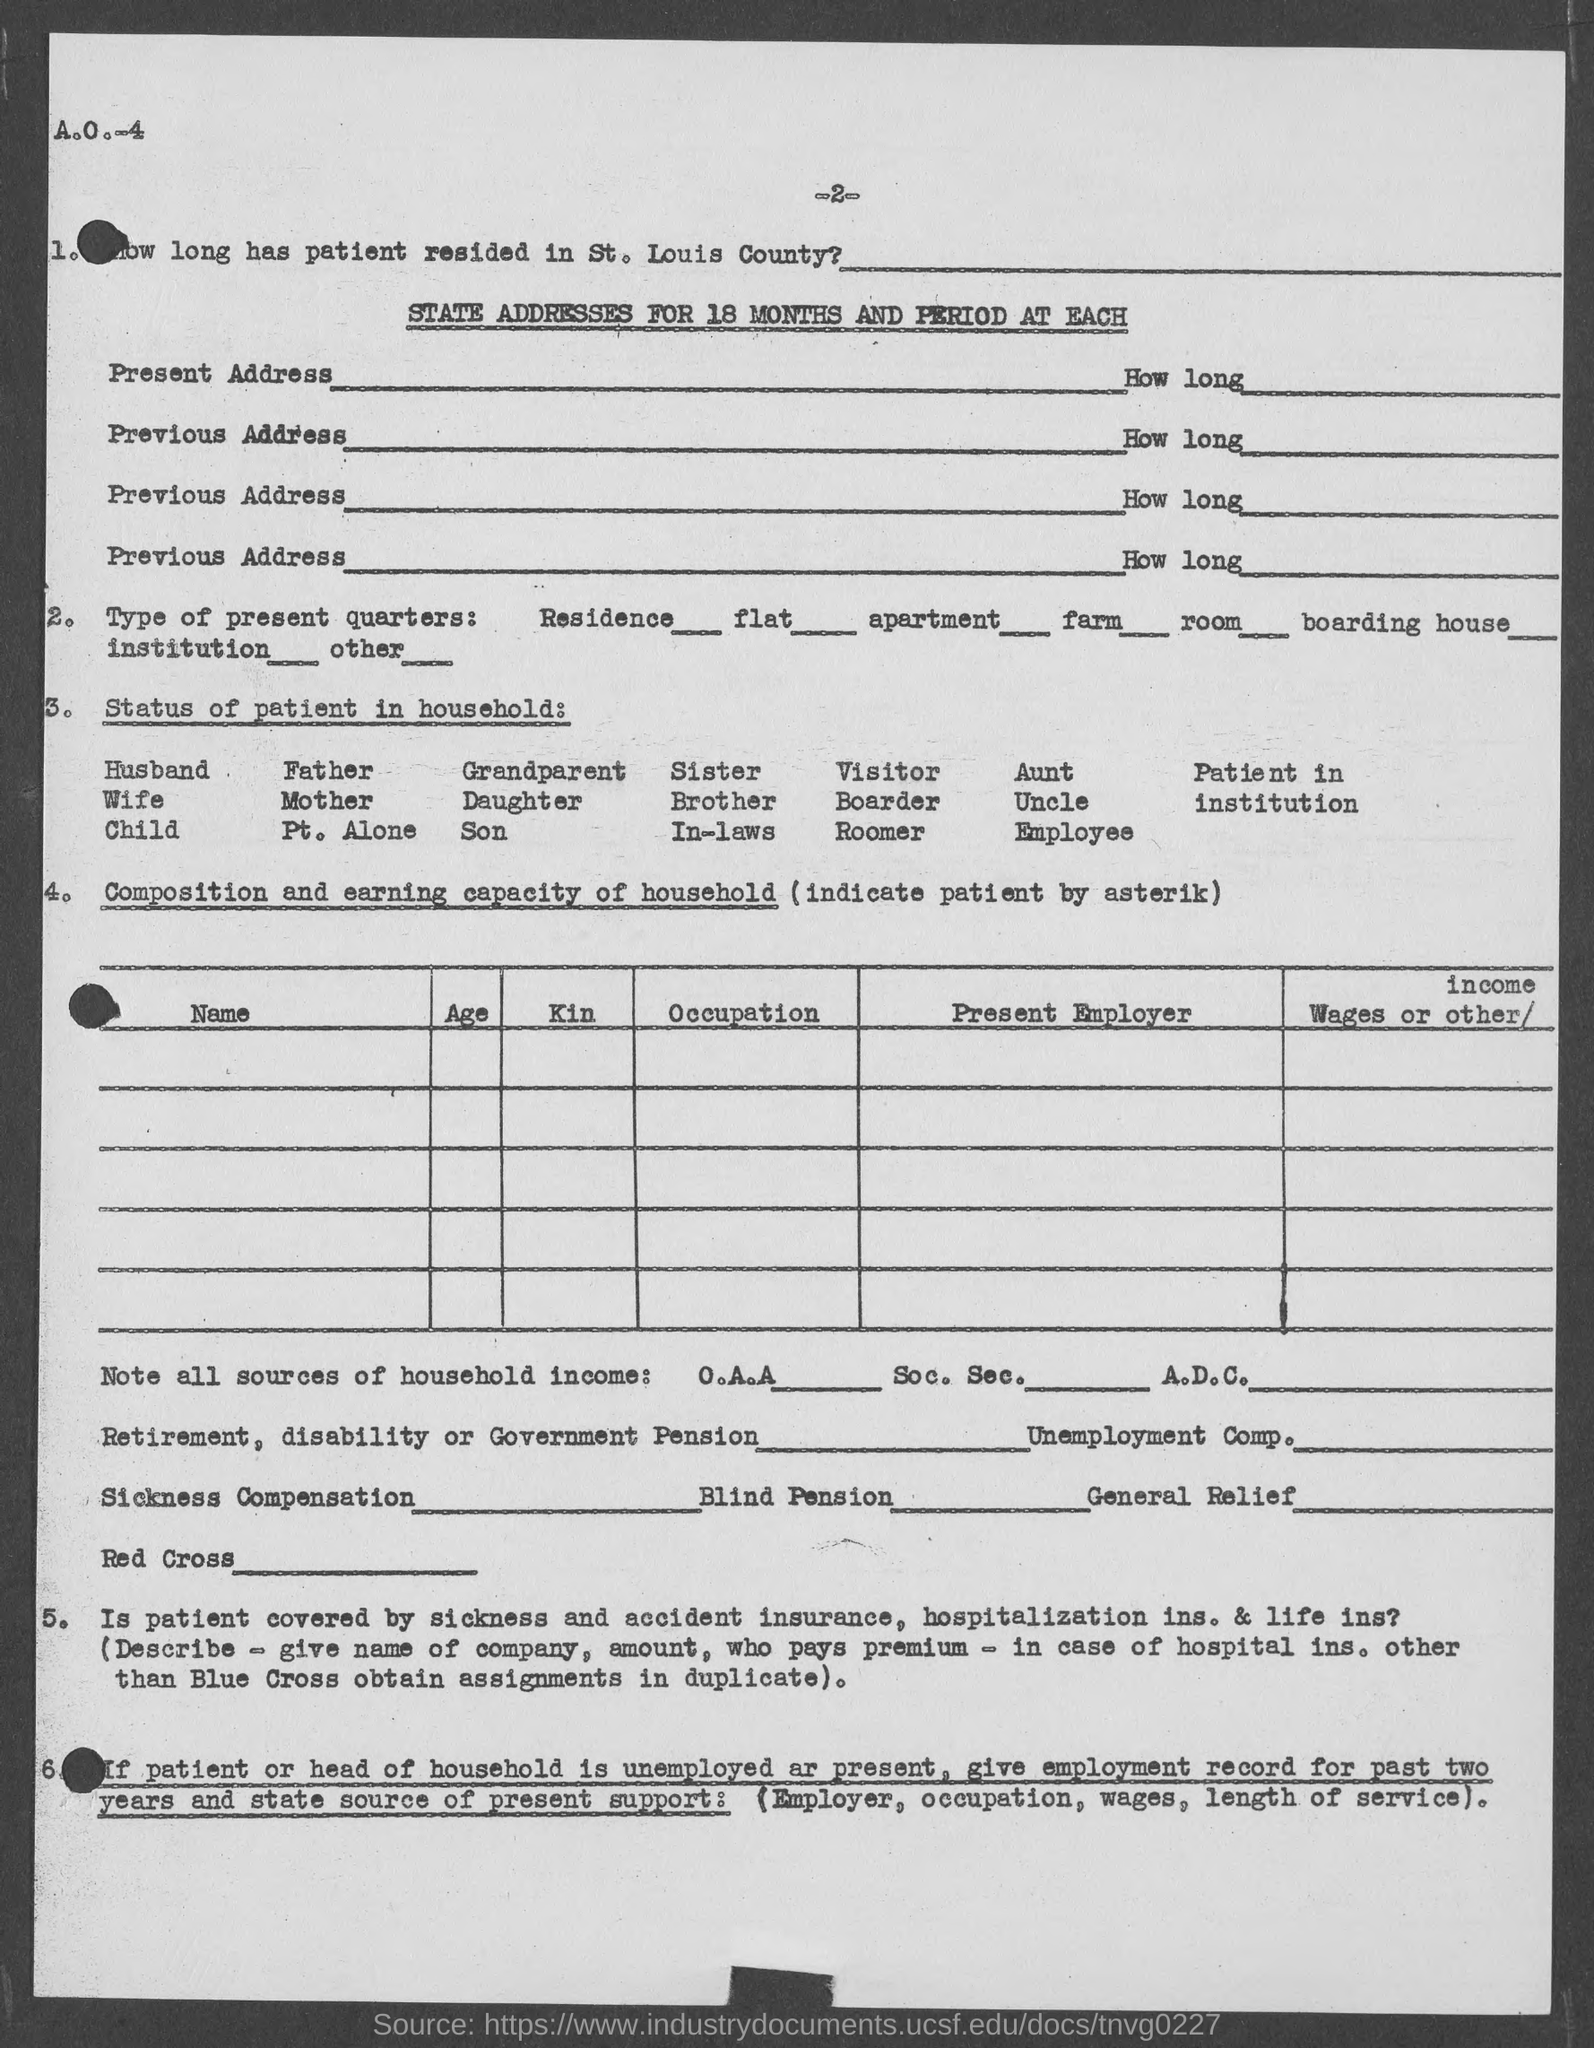Identify some key points in this picture. The number at the top of the page is 2. 